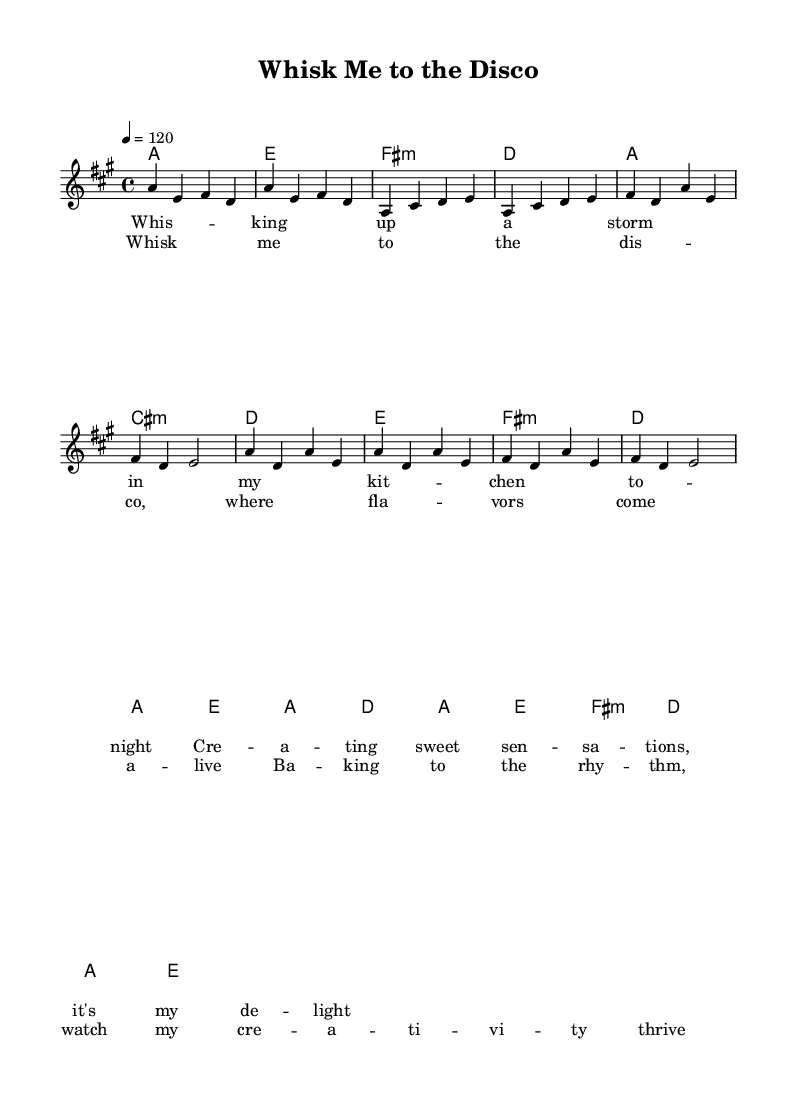What is the key signature of this music? The key signature indicates that the music is in A major, which has three sharps: F#, C#, and G#. This can be determined by looking at the key signature indicated at the beginning of the score.
Answer: A major What is the time signature of the piece? The time signature is displayed at the beginning of the score and indicates the number of beats in each measure. In this case, it is 4/4, meaning there are four beats in each measure and the quarter note gets one beat.
Answer: 4/4 What is the tempo marking of this music? The tempo marking is found at the beginning of the score, notated as "4 = 120," which indicates that there are 120 quarter note beats per minute.
Answer: 120 How many measures are there in the chorus? To find the number of measures in the chorus, we count the measures indicated separately from the verse. The chorus section consists of 8 measures.
Answer: 8 What is the function of the "Whisk me to the disco" section in the song? The "Whisk me to the disco" section serves as the chorus, which usually emphasizes the main theme or hook of the song. It often contrasts with the verse, providing a repetitive and catchy musical idea.
Answer: Chorus Which chord appears in both the verse and the chorus? By analyzing the chords listed in the harmonies section, we see that the chord "a" is present in both the verse and chorus sections multiple times.
Answer: a 